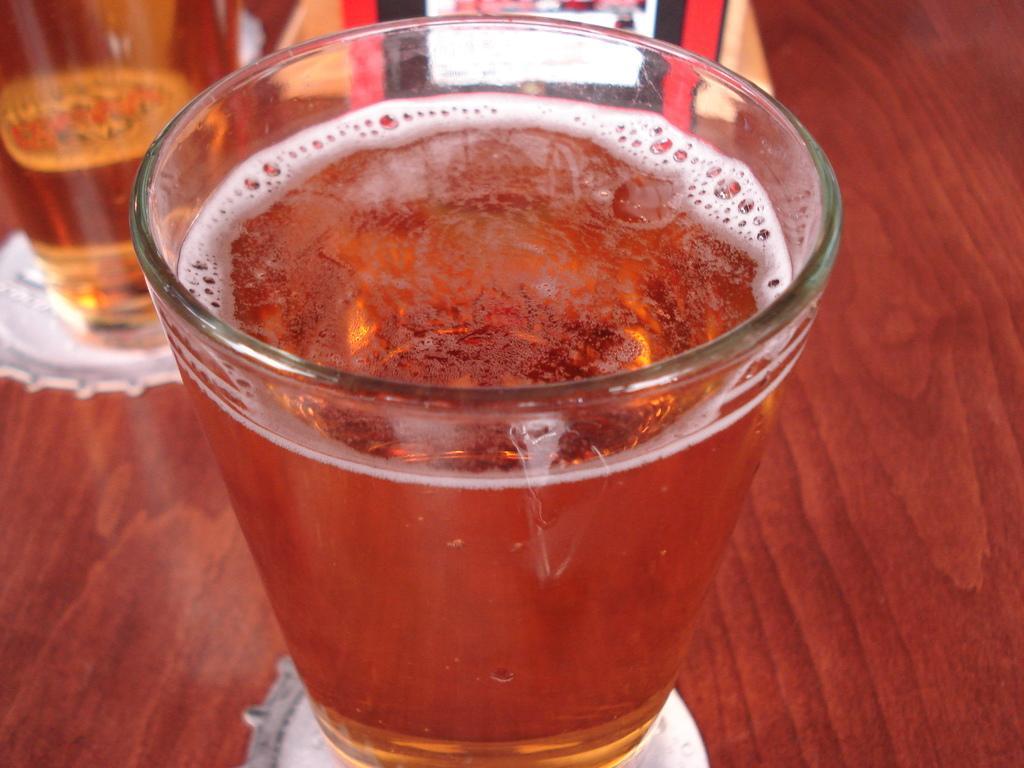How would you summarize this image in a sentence or two? In this image I can see a glass with liquid in it which is on the brown colored table. I can see another glass and few other objects on the table. 